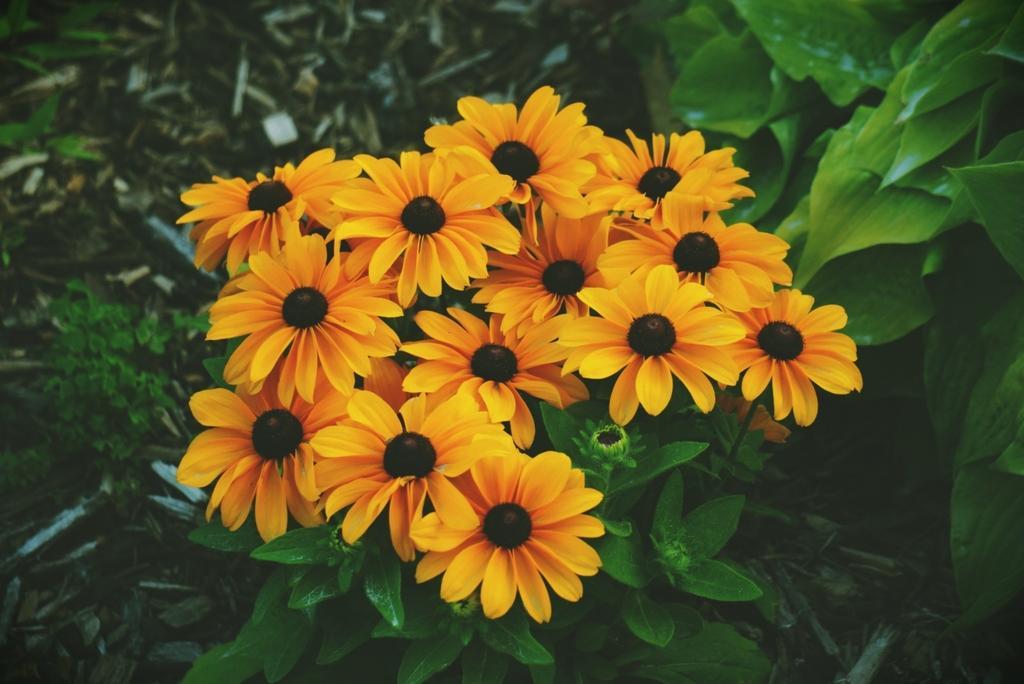Could you give a brief overview of what you see in this image? In this image I can see few flowers. They are in yellow and black color. I can see few green leaves. 